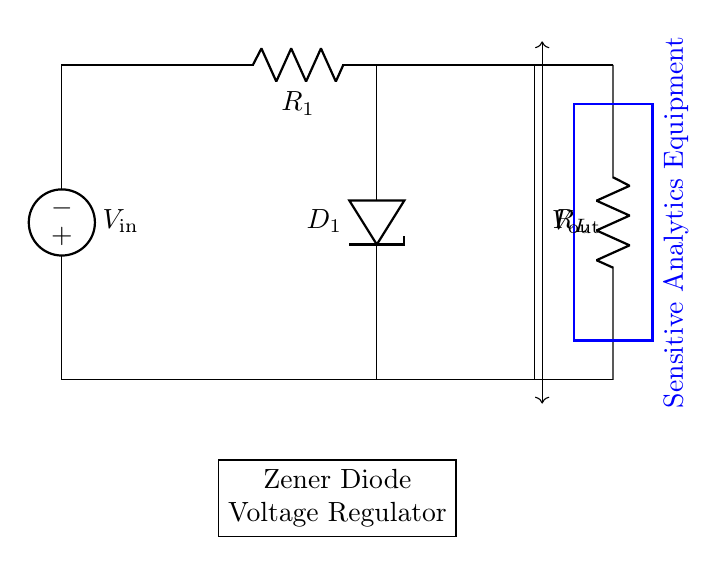What type of diode is used in this circuit? The diagram shows a Zener diode labeled as D1. Zener diodes are utilized for voltage regulation by allowing current to flow in the reverse direction when a specific reverse voltage is exceeded.
Answer: Zener diode What is the purpose of resistor R1 in this circuit? Resistor R1 limits the current flowing through the Zener diode and thus protects it from excessive current which could damage it. Its position in series with the input voltage ensures that the Zener diode operates within its specified limits.
Answer: Current limiting What is the role of the Zener diode in this circuit? The Zener diode regulates the output voltage by maintaining a constant voltage at its cathode when the input voltage exceeds its breakdown voltage. This is crucial to protect sensitive downstream equipment from voltage spikes.
Answer: Voltage regulation What is the output voltage labeled as in the circuit? The diagram identifies the output voltage as Vout, indicated by the arrow pointing to the space between the Zener diode and the load resistor R_L. This is the voltage applied to the sensitive analytics equipment.
Answer: Vout How does the arrangement of R_L affect the performance of the voltage regulation? Resistor R_L determines the load connected to the output. If R_L is too small (low resistance), it can draw excessive current, leading to a drop in the output voltage. A suitable value ensures the Zener diode can maintain the desired output voltage level under different load conditions.
Answer: Load stability What happens to the Zener diode if input voltage is below the breakdown voltage? If the input voltage is below the Zener diode's breakdown voltage, the diode does not conduct in reverse bias, and it essentially acts like an open circuit. Consequently, the output voltage equals the input voltage only if it's sufficient; otherwise, the output voltage will drop and the regulation fails.
Answer: No regulation 